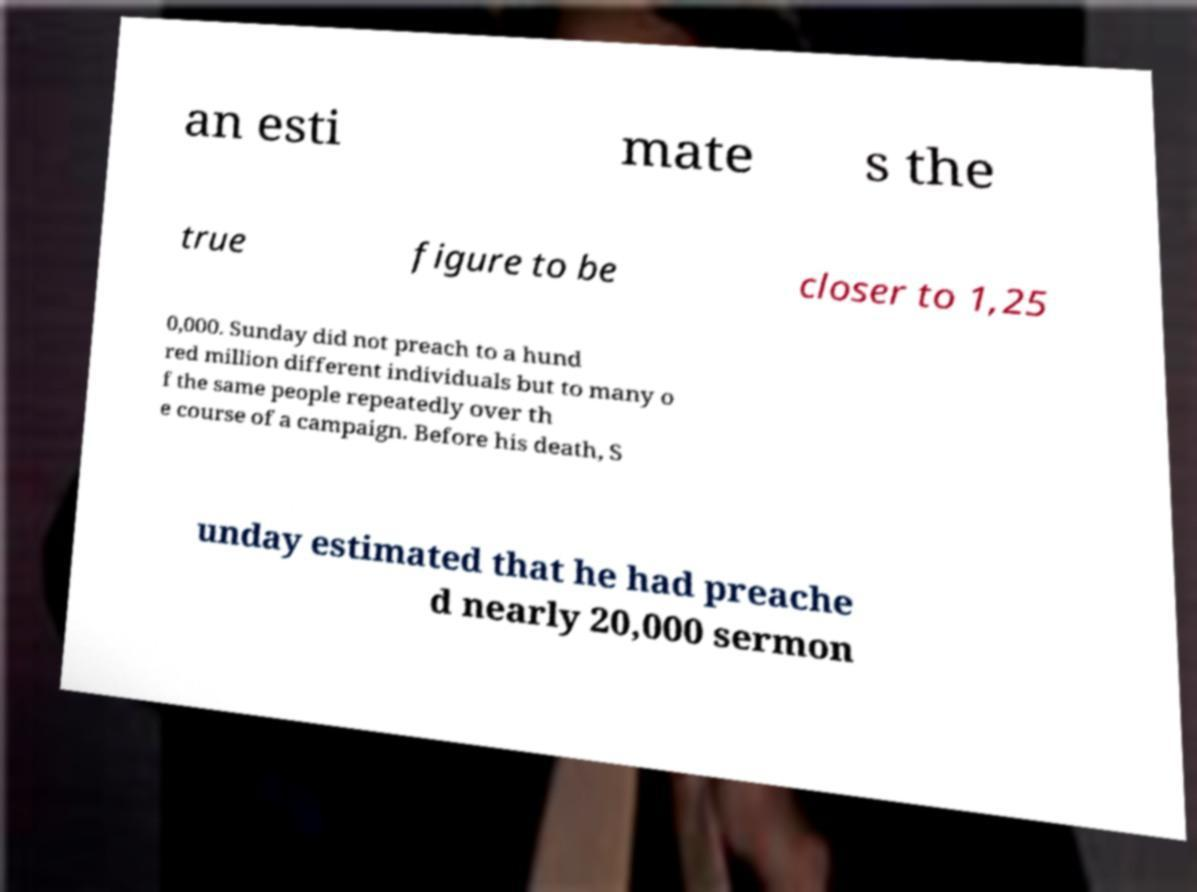Please identify and transcribe the text found in this image. an esti mate s the true figure to be closer to 1,25 0,000. Sunday did not preach to a hund red million different individuals but to many o f the same people repeatedly over th e course of a campaign. Before his death, S unday estimated that he had preache d nearly 20,000 sermon 